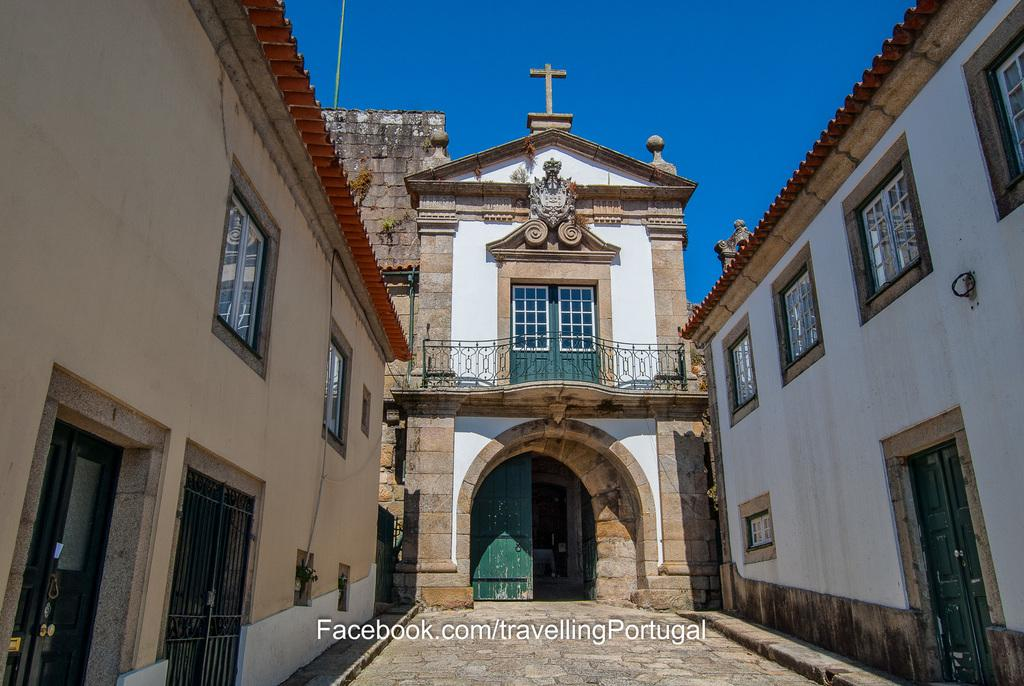What type of structures can be seen in the image? There are buildings in the image. What architectural feature is present at the bottom of the image? There is an arch at the bottom of the image. What part of the natural environment is visible in the image? The sky is visible in the background of the image. What color is the cast on the elbow of the person in the image? There is no person with a cast on their elbow present in the image. What type of material is used to construct the brick wall in the image? There is no brick wall present in the image. 